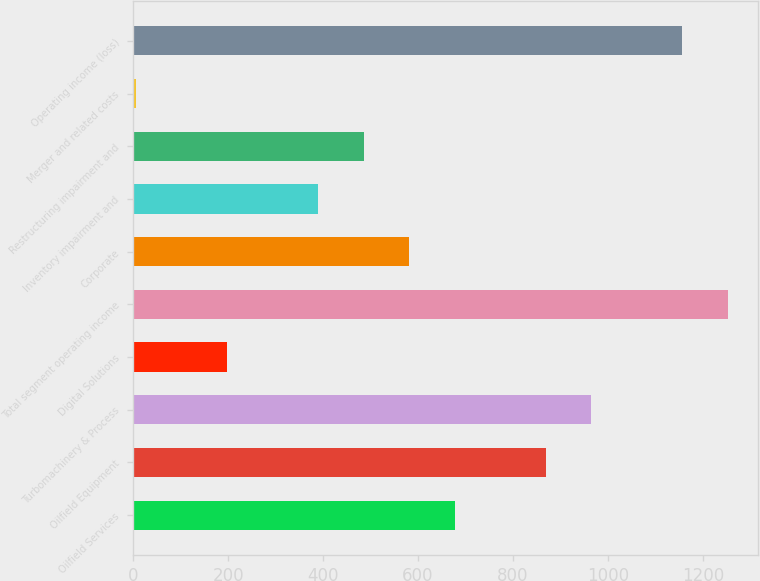Convert chart. <chart><loc_0><loc_0><loc_500><loc_500><bar_chart><fcel>Oilfield Services<fcel>Oilfield Equipment<fcel>Turbomachinery & Process<fcel>Digital Solutions<fcel>Total segment operating income<fcel>Corporate<fcel>Inventory impairment and<fcel>Restructuring impairment and<fcel>Merger and related costs<fcel>Operating income (loss)<nl><fcel>677.3<fcel>869.1<fcel>965<fcel>197.8<fcel>1252.7<fcel>581.4<fcel>389.6<fcel>485.5<fcel>6<fcel>1156.8<nl></chart> 